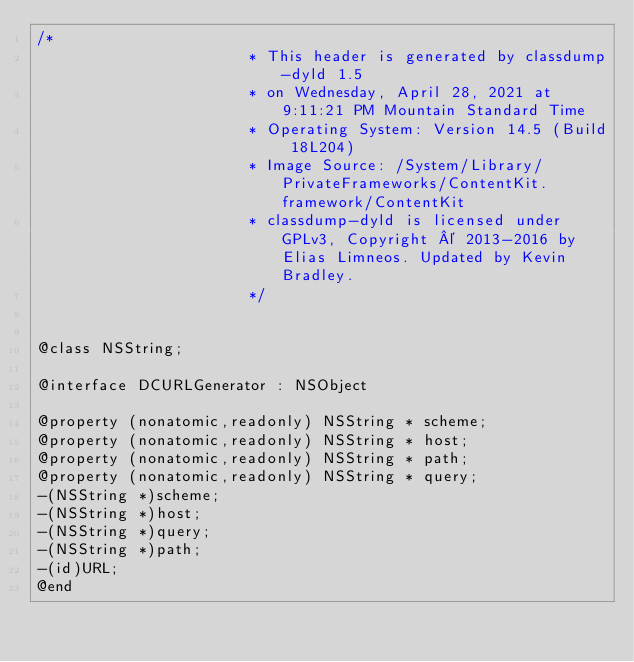Convert code to text. <code><loc_0><loc_0><loc_500><loc_500><_C_>/*
                       * This header is generated by classdump-dyld 1.5
                       * on Wednesday, April 28, 2021 at 9:11:21 PM Mountain Standard Time
                       * Operating System: Version 14.5 (Build 18L204)
                       * Image Source: /System/Library/PrivateFrameworks/ContentKit.framework/ContentKit
                       * classdump-dyld is licensed under GPLv3, Copyright © 2013-2016 by Elias Limneos. Updated by Kevin Bradley.
                       */


@class NSString;

@interface DCURLGenerator : NSObject

@property (nonatomic,readonly) NSString * scheme; 
@property (nonatomic,readonly) NSString * host; 
@property (nonatomic,readonly) NSString * path; 
@property (nonatomic,readonly) NSString * query; 
-(NSString *)scheme;
-(NSString *)host;
-(NSString *)query;
-(NSString *)path;
-(id)URL;
@end

</code> 